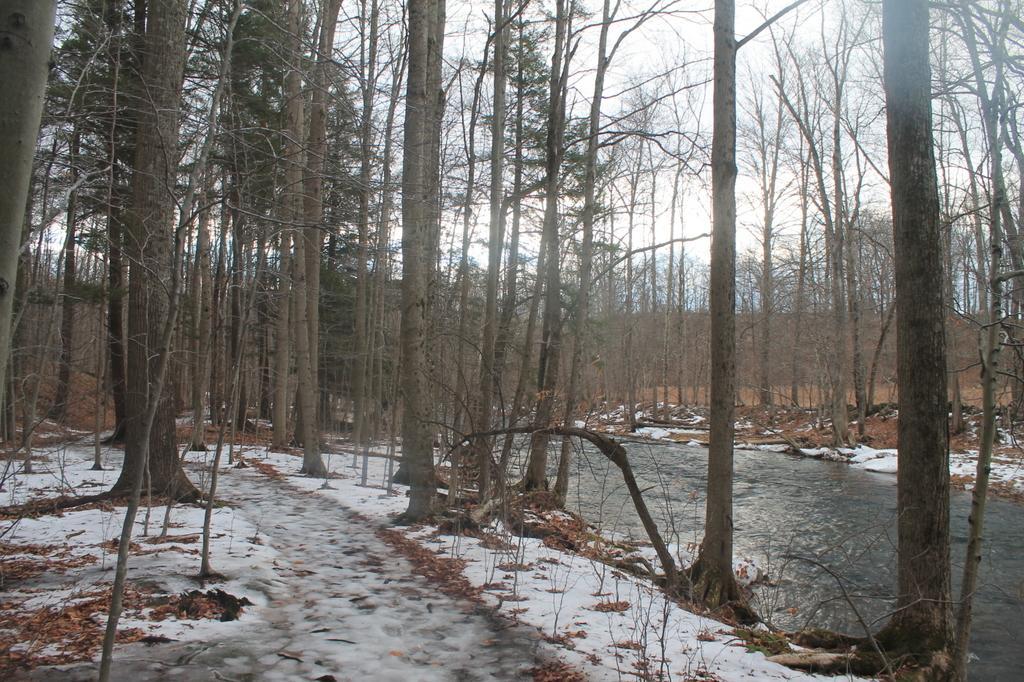Describe this image in one or two sentences. In this image there is a ground in the bottom left corner of this image and there is a water on the right side of this image. There are some trees in the background. 